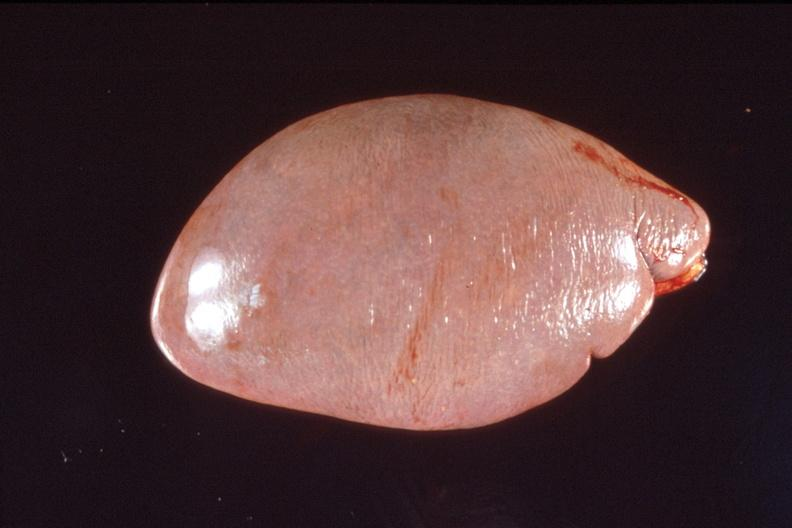where is this part in?
Answer the question using a single word or phrase. Spleen 